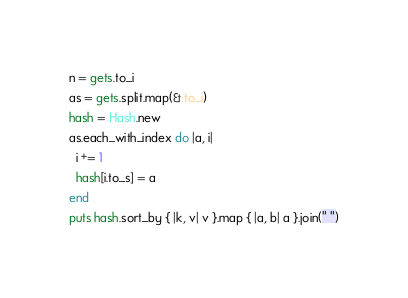<code> <loc_0><loc_0><loc_500><loc_500><_Ruby_>n = gets.to_i
as = gets.split.map(&:to_i)
hash = Hash.new
as.each_with_index do |a, i|
  i += 1
  hash[i.to_s] = a
end
puts hash.sort_by { |k, v| v }.map { |a, b| a }.join(" ")</code> 